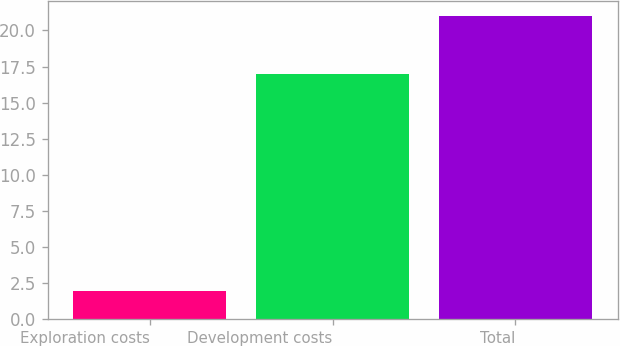<chart> <loc_0><loc_0><loc_500><loc_500><bar_chart><fcel>Exploration costs<fcel>Development costs<fcel>Total<nl><fcel>2<fcel>17<fcel>21<nl></chart> 